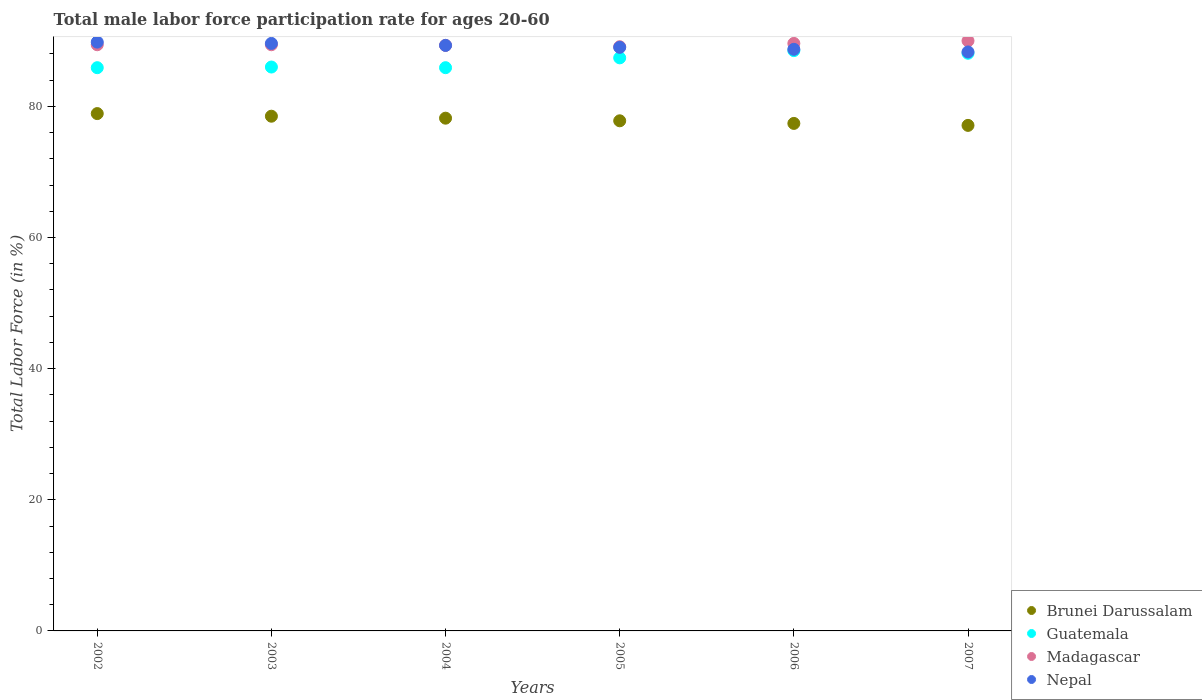How many different coloured dotlines are there?
Your response must be concise. 4. Is the number of dotlines equal to the number of legend labels?
Make the answer very short. Yes. What is the male labor force participation rate in Madagascar in 2004?
Offer a terse response. 89.3. Across all years, what is the minimum male labor force participation rate in Brunei Darussalam?
Your answer should be very brief. 77.1. In which year was the male labor force participation rate in Madagascar maximum?
Your answer should be very brief. 2007. In which year was the male labor force participation rate in Madagascar minimum?
Offer a terse response. 2005. What is the total male labor force participation rate in Madagascar in the graph?
Keep it short and to the point. 536.8. What is the difference between the male labor force participation rate in Nepal in 2003 and that in 2005?
Keep it short and to the point. 0.6. What is the difference between the male labor force participation rate in Nepal in 2003 and the male labor force participation rate in Guatemala in 2007?
Provide a succinct answer. 1.5. What is the average male labor force participation rate in Brunei Darussalam per year?
Give a very brief answer. 77.98. In the year 2005, what is the difference between the male labor force participation rate in Nepal and male labor force participation rate in Guatemala?
Provide a succinct answer. 1.6. In how many years, is the male labor force participation rate in Nepal greater than 52 %?
Offer a terse response. 6. What is the ratio of the male labor force participation rate in Nepal in 2002 to that in 2005?
Your response must be concise. 1.01. Is the male labor force participation rate in Guatemala in 2004 less than that in 2005?
Offer a very short reply. Yes. What is the difference between the highest and the second highest male labor force participation rate in Madagascar?
Provide a short and direct response. 0.4. What is the difference between the highest and the lowest male labor force participation rate in Guatemala?
Offer a terse response. 2.6. In how many years, is the male labor force participation rate in Brunei Darussalam greater than the average male labor force participation rate in Brunei Darussalam taken over all years?
Ensure brevity in your answer.  3. Does the male labor force participation rate in Madagascar monotonically increase over the years?
Give a very brief answer. No. How many dotlines are there?
Your answer should be compact. 4. What is the difference between two consecutive major ticks on the Y-axis?
Give a very brief answer. 20. Are the values on the major ticks of Y-axis written in scientific E-notation?
Make the answer very short. No. How are the legend labels stacked?
Provide a short and direct response. Vertical. What is the title of the graph?
Your answer should be compact. Total male labor force participation rate for ages 20-60. What is the label or title of the X-axis?
Ensure brevity in your answer.  Years. What is the Total Labor Force (in %) of Brunei Darussalam in 2002?
Make the answer very short. 78.9. What is the Total Labor Force (in %) in Guatemala in 2002?
Give a very brief answer. 85.9. What is the Total Labor Force (in %) in Madagascar in 2002?
Give a very brief answer. 89.4. What is the Total Labor Force (in %) in Nepal in 2002?
Your response must be concise. 89.8. What is the Total Labor Force (in %) of Brunei Darussalam in 2003?
Your answer should be compact. 78.5. What is the Total Labor Force (in %) of Madagascar in 2003?
Give a very brief answer. 89.4. What is the Total Labor Force (in %) in Nepal in 2003?
Your response must be concise. 89.6. What is the Total Labor Force (in %) in Brunei Darussalam in 2004?
Offer a terse response. 78.2. What is the Total Labor Force (in %) in Guatemala in 2004?
Provide a succinct answer. 85.9. What is the Total Labor Force (in %) of Madagascar in 2004?
Ensure brevity in your answer.  89.3. What is the Total Labor Force (in %) of Nepal in 2004?
Offer a terse response. 89.3. What is the Total Labor Force (in %) of Brunei Darussalam in 2005?
Provide a succinct answer. 77.8. What is the Total Labor Force (in %) in Guatemala in 2005?
Provide a short and direct response. 87.4. What is the Total Labor Force (in %) of Madagascar in 2005?
Your answer should be compact. 89.1. What is the Total Labor Force (in %) of Nepal in 2005?
Make the answer very short. 89. What is the Total Labor Force (in %) in Brunei Darussalam in 2006?
Ensure brevity in your answer.  77.4. What is the Total Labor Force (in %) of Guatemala in 2006?
Offer a very short reply. 88.5. What is the Total Labor Force (in %) of Madagascar in 2006?
Provide a succinct answer. 89.6. What is the Total Labor Force (in %) of Nepal in 2006?
Your response must be concise. 88.7. What is the Total Labor Force (in %) in Brunei Darussalam in 2007?
Give a very brief answer. 77.1. What is the Total Labor Force (in %) of Guatemala in 2007?
Provide a short and direct response. 88.1. What is the Total Labor Force (in %) in Nepal in 2007?
Provide a succinct answer. 88.3. Across all years, what is the maximum Total Labor Force (in %) of Brunei Darussalam?
Offer a terse response. 78.9. Across all years, what is the maximum Total Labor Force (in %) in Guatemala?
Make the answer very short. 88.5. Across all years, what is the maximum Total Labor Force (in %) in Nepal?
Keep it short and to the point. 89.8. Across all years, what is the minimum Total Labor Force (in %) of Brunei Darussalam?
Provide a succinct answer. 77.1. Across all years, what is the minimum Total Labor Force (in %) in Guatemala?
Provide a succinct answer. 85.9. Across all years, what is the minimum Total Labor Force (in %) in Madagascar?
Your answer should be very brief. 89.1. Across all years, what is the minimum Total Labor Force (in %) in Nepal?
Your answer should be very brief. 88.3. What is the total Total Labor Force (in %) of Brunei Darussalam in the graph?
Ensure brevity in your answer.  467.9. What is the total Total Labor Force (in %) of Guatemala in the graph?
Your response must be concise. 521.8. What is the total Total Labor Force (in %) in Madagascar in the graph?
Make the answer very short. 536.8. What is the total Total Labor Force (in %) in Nepal in the graph?
Your answer should be very brief. 534.7. What is the difference between the Total Labor Force (in %) in Brunei Darussalam in 2002 and that in 2003?
Your answer should be very brief. 0.4. What is the difference between the Total Labor Force (in %) of Guatemala in 2002 and that in 2003?
Your answer should be compact. -0.1. What is the difference between the Total Labor Force (in %) in Madagascar in 2002 and that in 2003?
Keep it short and to the point. 0. What is the difference between the Total Labor Force (in %) in Nepal in 2002 and that in 2003?
Offer a very short reply. 0.2. What is the difference between the Total Labor Force (in %) of Madagascar in 2002 and that in 2004?
Keep it short and to the point. 0.1. What is the difference between the Total Labor Force (in %) of Nepal in 2002 and that in 2004?
Keep it short and to the point. 0.5. What is the difference between the Total Labor Force (in %) of Madagascar in 2002 and that in 2005?
Your answer should be very brief. 0.3. What is the difference between the Total Labor Force (in %) in Guatemala in 2002 and that in 2006?
Offer a terse response. -2.6. What is the difference between the Total Labor Force (in %) in Madagascar in 2002 and that in 2006?
Provide a short and direct response. -0.2. What is the difference between the Total Labor Force (in %) of Nepal in 2002 and that in 2006?
Make the answer very short. 1.1. What is the difference between the Total Labor Force (in %) in Brunei Darussalam in 2002 and that in 2007?
Provide a succinct answer. 1.8. What is the difference between the Total Labor Force (in %) of Guatemala in 2002 and that in 2007?
Make the answer very short. -2.2. What is the difference between the Total Labor Force (in %) in Nepal in 2002 and that in 2007?
Your answer should be very brief. 1.5. What is the difference between the Total Labor Force (in %) of Brunei Darussalam in 2003 and that in 2004?
Ensure brevity in your answer.  0.3. What is the difference between the Total Labor Force (in %) of Madagascar in 2003 and that in 2004?
Offer a very short reply. 0.1. What is the difference between the Total Labor Force (in %) in Nepal in 2003 and that in 2004?
Give a very brief answer. 0.3. What is the difference between the Total Labor Force (in %) in Guatemala in 2003 and that in 2006?
Offer a very short reply. -2.5. What is the difference between the Total Labor Force (in %) in Madagascar in 2003 and that in 2006?
Keep it short and to the point. -0.2. What is the difference between the Total Labor Force (in %) of Brunei Darussalam in 2003 and that in 2007?
Provide a succinct answer. 1.4. What is the difference between the Total Labor Force (in %) in Brunei Darussalam in 2004 and that in 2005?
Provide a succinct answer. 0.4. What is the difference between the Total Labor Force (in %) in Guatemala in 2004 and that in 2005?
Offer a very short reply. -1.5. What is the difference between the Total Labor Force (in %) of Madagascar in 2004 and that in 2005?
Make the answer very short. 0.2. What is the difference between the Total Labor Force (in %) of Nepal in 2004 and that in 2005?
Provide a succinct answer. 0.3. What is the difference between the Total Labor Force (in %) of Guatemala in 2004 and that in 2006?
Your answer should be very brief. -2.6. What is the difference between the Total Labor Force (in %) in Nepal in 2004 and that in 2006?
Offer a very short reply. 0.6. What is the difference between the Total Labor Force (in %) in Guatemala in 2005 and that in 2006?
Provide a succinct answer. -1.1. What is the difference between the Total Labor Force (in %) in Madagascar in 2005 and that in 2006?
Provide a short and direct response. -0.5. What is the difference between the Total Labor Force (in %) in Guatemala in 2005 and that in 2007?
Your response must be concise. -0.7. What is the difference between the Total Labor Force (in %) of Madagascar in 2005 and that in 2007?
Give a very brief answer. -0.9. What is the difference between the Total Labor Force (in %) in Brunei Darussalam in 2006 and that in 2007?
Offer a terse response. 0.3. What is the difference between the Total Labor Force (in %) of Guatemala in 2006 and that in 2007?
Your answer should be compact. 0.4. What is the difference between the Total Labor Force (in %) of Nepal in 2006 and that in 2007?
Your answer should be very brief. 0.4. What is the difference between the Total Labor Force (in %) in Brunei Darussalam in 2002 and the Total Labor Force (in %) in Guatemala in 2003?
Offer a terse response. -7.1. What is the difference between the Total Labor Force (in %) of Brunei Darussalam in 2002 and the Total Labor Force (in %) of Nepal in 2003?
Make the answer very short. -10.7. What is the difference between the Total Labor Force (in %) of Madagascar in 2002 and the Total Labor Force (in %) of Nepal in 2003?
Offer a very short reply. -0.2. What is the difference between the Total Labor Force (in %) in Guatemala in 2002 and the Total Labor Force (in %) in Madagascar in 2004?
Your answer should be compact. -3.4. What is the difference between the Total Labor Force (in %) in Brunei Darussalam in 2002 and the Total Labor Force (in %) in Guatemala in 2005?
Keep it short and to the point. -8.5. What is the difference between the Total Labor Force (in %) of Brunei Darussalam in 2002 and the Total Labor Force (in %) of Nepal in 2005?
Provide a short and direct response. -10.1. What is the difference between the Total Labor Force (in %) of Guatemala in 2002 and the Total Labor Force (in %) of Nepal in 2005?
Give a very brief answer. -3.1. What is the difference between the Total Labor Force (in %) of Brunei Darussalam in 2002 and the Total Labor Force (in %) of Guatemala in 2006?
Ensure brevity in your answer.  -9.6. What is the difference between the Total Labor Force (in %) of Brunei Darussalam in 2002 and the Total Labor Force (in %) of Madagascar in 2006?
Provide a short and direct response. -10.7. What is the difference between the Total Labor Force (in %) in Brunei Darussalam in 2002 and the Total Labor Force (in %) in Nepal in 2006?
Provide a succinct answer. -9.8. What is the difference between the Total Labor Force (in %) in Brunei Darussalam in 2002 and the Total Labor Force (in %) in Guatemala in 2007?
Your answer should be compact. -9.2. What is the difference between the Total Labor Force (in %) of Brunei Darussalam in 2002 and the Total Labor Force (in %) of Nepal in 2007?
Provide a short and direct response. -9.4. What is the difference between the Total Labor Force (in %) of Guatemala in 2002 and the Total Labor Force (in %) of Madagascar in 2007?
Your response must be concise. -4.1. What is the difference between the Total Labor Force (in %) of Guatemala in 2002 and the Total Labor Force (in %) of Nepal in 2007?
Your response must be concise. -2.4. What is the difference between the Total Labor Force (in %) of Brunei Darussalam in 2003 and the Total Labor Force (in %) of Guatemala in 2004?
Keep it short and to the point. -7.4. What is the difference between the Total Labor Force (in %) in Brunei Darussalam in 2003 and the Total Labor Force (in %) in Madagascar in 2004?
Offer a terse response. -10.8. What is the difference between the Total Labor Force (in %) of Madagascar in 2003 and the Total Labor Force (in %) of Nepal in 2004?
Your response must be concise. 0.1. What is the difference between the Total Labor Force (in %) in Brunei Darussalam in 2003 and the Total Labor Force (in %) in Nepal in 2005?
Provide a succinct answer. -10.5. What is the difference between the Total Labor Force (in %) of Guatemala in 2003 and the Total Labor Force (in %) of Nepal in 2005?
Ensure brevity in your answer.  -3. What is the difference between the Total Labor Force (in %) in Brunei Darussalam in 2003 and the Total Labor Force (in %) in Guatemala in 2006?
Keep it short and to the point. -10. What is the difference between the Total Labor Force (in %) in Brunei Darussalam in 2003 and the Total Labor Force (in %) in Madagascar in 2006?
Give a very brief answer. -11.1. What is the difference between the Total Labor Force (in %) in Guatemala in 2003 and the Total Labor Force (in %) in Madagascar in 2006?
Your response must be concise. -3.6. What is the difference between the Total Labor Force (in %) of Madagascar in 2003 and the Total Labor Force (in %) of Nepal in 2006?
Provide a short and direct response. 0.7. What is the difference between the Total Labor Force (in %) in Brunei Darussalam in 2003 and the Total Labor Force (in %) in Guatemala in 2007?
Offer a terse response. -9.6. What is the difference between the Total Labor Force (in %) of Brunei Darussalam in 2003 and the Total Labor Force (in %) of Madagascar in 2007?
Provide a short and direct response. -11.5. What is the difference between the Total Labor Force (in %) of Guatemala in 2003 and the Total Labor Force (in %) of Madagascar in 2007?
Provide a short and direct response. -4. What is the difference between the Total Labor Force (in %) in Guatemala in 2003 and the Total Labor Force (in %) in Nepal in 2007?
Your answer should be very brief. -2.3. What is the difference between the Total Labor Force (in %) of Brunei Darussalam in 2004 and the Total Labor Force (in %) of Guatemala in 2005?
Give a very brief answer. -9.2. What is the difference between the Total Labor Force (in %) in Brunei Darussalam in 2004 and the Total Labor Force (in %) in Madagascar in 2005?
Offer a terse response. -10.9. What is the difference between the Total Labor Force (in %) in Brunei Darussalam in 2004 and the Total Labor Force (in %) in Nepal in 2005?
Offer a terse response. -10.8. What is the difference between the Total Labor Force (in %) in Madagascar in 2004 and the Total Labor Force (in %) in Nepal in 2005?
Provide a short and direct response. 0.3. What is the difference between the Total Labor Force (in %) of Brunei Darussalam in 2004 and the Total Labor Force (in %) of Guatemala in 2006?
Make the answer very short. -10.3. What is the difference between the Total Labor Force (in %) in Brunei Darussalam in 2004 and the Total Labor Force (in %) in Nepal in 2006?
Give a very brief answer. -10.5. What is the difference between the Total Labor Force (in %) of Guatemala in 2004 and the Total Labor Force (in %) of Nepal in 2006?
Make the answer very short. -2.8. What is the difference between the Total Labor Force (in %) of Brunei Darussalam in 2004 and the Total Labor Force (in %) of Guatemala in 2007?
Give a very brief answer. -9.9. What is the difference between the Total Labor Force (in %) of Brunei Darussalam in 2004 and the Total Labor Force (in %) of Nepal in 2007?
Provide a succinct answer. -10.1. What is the difference between the Total Labor Force (in %) of Brunei Darussalam in 2005 and the Total Labor Force (in %) of Guatemala in 2006?
Your answer should be compact. -10.7. What is the difference between the Total Labor Force (in %) of Brunei Darussalam in 2005 and the Total Labor Force (in %) of Nepal in 2006?
Give a very brief answer. -10.9. What is the difference between the Total Labor Force (in %) of Guatemala in 2005 and the Total Labor Force (in %) of Madagascar in 2006?
Offer a terse response. -2.2. What is the difference between the Total Labor Force (in %) in Guatemala in 2005 and the Total Labor Force (in %) in Nepal in 2006?
Give a very brief answer. -1.3. What is the difference between the Total Labor Force (in %) in Madagascar in 2005 and the Total Labor Force (in %) in Nepal in 2006?
Ensure brevity in your answer.  0.4. What is the difference between the Total Labor Force (in %) of Brunei Darussalam in 2006 and the Total Labor Force (in %) of Guatemala in 2007?
Give a very brief answer. -10.7. What is the difference between the Total Labor Force (in %) of Brunei Darussalam in 2006 and the Total Labor Force (in %) of Madagascar in 2007?
Provide a succinct answer. -12.6. What is the difference between the Total Labor Force (in %) of Brunei Darussalam in 2006 and the Total Labor Force (in %) of Nepal in 2007?
Provide a succinct answer. -10.9. What is the difference between the Total Labor Force (in %) in Madagascar in 2006 and the Total Labor Force (in %) in Nepal in 2007?
Your response must be concise. 1.3. What is the average Total Labor Force (in %) of Brunei Darussalam per year?
Provide a succinct answer. 77.98. What is the average Total Labor Force (in %) of Guatemala per year?
Keep it short and to the point. 86.97. What is the average Total Labor Force (in %) in Madagascar per year?
Make the answer very short. 89.47. What is the average Total Labor Force (in %) in Nepal per year?
Your answer should be compact. 89.12. In the year 2002, what is the difference between the Total Labor Force (in %) in Brunei Darussalam and Total Labor Force (in %) in Guatemala?
Provide a short and direct response. -7. In the year 2002, what is the difference between the Total Labor Force (in %) of Brunei Darussalam and Total Labor Force (in %) of Madagascar?
Offer a terse response. -10.5. In the year 2002, what is the difference between the Total Labor Force (in %) in Brunei Darussalam and Total Labor Force (in %) in Nepal?
Your answer should be very brief. -10.9. In the year 2002, what is the difference between the Total Labor Force (in %) of Madagascar and Total Labor Force (in %) of Nepal?
Your response must be concise. -0.4. In the year 2003, what is the difference between the Total Labor Force (in %) of Brunei Darussalam and Total Labor Force (in %) of Nepal?
Your answer should be very brief. -11.1. In the year 2003, what is the difference between the Total Labor Force (in %) in Guatemala and Total Labor Force (in %) in Nepal?
Make the answer very short. -3.6. In the year 2004, what is the difference between the Total Labor Force (in %) of Brunei Darussalam and Total Labor Force (in %) of Guatemala?
Your response must be concise. -7.7. In the year 2004, what is the difference between the Total Labor Force (in %) of Brunei Darussalam and Total Labor Force (in %) of Madagascar?
Give a very brief answer. -11.1. In the year 2004, what is the difference between the Total Labor Force (in %) in Brunei Darussalam and Total Labor Force (in %) in Nepal?
Offer a terse response. -11.1. In the year 2004, what is the difference between the Total Labor Force (in %) in Guatemala and Total Labor Force (in %) in Nepal?
Your response must be concise. -3.4. In the year 2005, what is the difference between the Total Labor Force (in %) in Brunei Darussalam and Total Labor Force (in %) in Madagascar?
Give a very brief answer. -11.3. In the year 2005, what is the difference between the Total Labor Force (in %) of Brunei Darussalam and Total Labor Force (in %) of Nepal?
Provide a succinct answer. -11.2. In the year 2005, what is the difference between the Total Labor Force (in %) in Guatemala and Total Labor Force (in %) in Madagascar?
Provide a succinct answer. -1.7. In the year 2006, what is the difference between the Total Labor Force (in %) in Brunei Darussalam and Total Labor Force (in %) in Guatemala?
Offer a terse response. -11.1. In the year 2006, what is the difference between the Total Labor Force (in %) in Brunei Darussalam and Total Labor Force (in %) in Madagascar?
Give a very brief answer. -12.2. In the year 2006, what is the difference between the Total Labor Force (in %) of Guatemala and Total Labor Force (in %) of Nepal?
Offer a very short reply. -0.2. In the year 2007, what is the difference between the Total Labor Force (in %) in Brunei Darussalam and Total Labor Force (in %) in Guatemala?
Keep it short and to the point. -11. In the year 2007, what is the difference between the Total Labor Force (in %) of Brunei Darussalam and Total Labor Force (in %) of Madagascar?
Provide a succinct answer. -12.9. In the year 2007, what is the difference between the Total Labor Force (in %) of Guatemala and Total Labor Force (in %) of Nepal?
Your answer should be very brief. -0.2. What is the ratio of the Total Labor Force (in %) in Madagascar in 2002 to that in 2003?
Provide a short and direct response. 1. What is the ratio of the Total Labor Force (in %) of Brunei Darussalam in 2002 to that in 2004?
Provide a succinct answer. 1.01. What is the ratio of the Total Labor Force (in %) in Nepal in 2002 to that in 2004?
Your answer should be compact. 1.01. What is the ratio of the Total Labor Force (in %) in Brunei Darussalam in 2002 to that in 2005?
Offer a terse response. 1.01. What is the ratio of the Total Labor Force (in %) in Guatemala in 2002 to that in 2005?
Give a very brief answer. 0.98. What is the ratio of the Total Labor Force (in %) of Madagascar in 2002 to that in 2005?
Your answer should be compact. 1. What is the ratio of the Total Labor Force (in %) of Nepal in 2002 to that in 2005?
Provide a succinct answer. 1.01. What is the ratio of the Total Labor Force (in %) in Brunei Darussalam in 2002 to that in 2006?
Keep it short and to the point. 1.02. What is the ratio of the Total Labor Force (in %) in Guatemala in 2002 to that in 2006?
Ensure brevity in your answer.  0.97. What is the ratio of the Total Labor Force (in %) of Nepal in 2002 to that in 2006?
Your response must be concise. 1.01. What is the ratio of the Total Labor Force (in %) in Brunei Darussalam in 2002 to that in 2007?
Offer a terse response. 1.02. What is the ratio of the Total Labor Force (in %) of Guatemala in 2002 to that in 2007?
Your answer should be compact. 0.97. What is the ratio of the Total Labor Force (in %) of Brunei Darussalam in 2003 to that in 2004?
Give a very brief answer. 1. What is the ratio of the Total Labor Force (in %) in Madagascar in 2003 to that in 2004?
Your response must be concise. 1. What is the ratio of the Total Labor Force (in %) of Nepal in 2003 to that in 2004?
Provide a succinct answer. 1. What is the ratio of the Total Labor Force (in %) in Brunei Darussalam in 2003 to that in 2005?
Provide a short and direct response. 1.01. What is the ratio of the Total Labor Force (in %) in Brunei Darussalam in 2003 to that in 2006?
Make the answer very short. 1.01. What is the ratio of the Total Labor Force (in %) of Guatemala in 2003 to that in 2006?
Your response must be concise. 0.97. What is the ratio of the Total Labor Force (in %) of Nepal in 2003 to that in 2006?
Keep it short and to the point. 1.01. What is the ratio of the Total Labor Force (in %) of Brunei Darussalam in 2003 to that in 2007?
Your answer should be compact. 1.02. What is the ratio of the Total Labor Force (in %) in Guatemala in 2003 to that in 2007?
Keep it short and to the point. 0.98. What is the ratio of the Total Labor Force (in %) in Madagascar in 2003 to that in 2007?
Make the answer very short. 0.99. What is the ratio of the Total Labor Force (in %) of Nepal in 2003 to that in 2007?
Provide a succinct answer. 1.01. What is the ratio of the Total Labor Force (in %) of Guatemala in 2004 to that in 2005?
Make the answer very short. 0.98. What is the ratio of the Total Labor Force (in %) of Brunei Darussalam in 2004 to that in 2006?
Offer a very short reply. 1.01. What is the ratio of the Total Labor Force (in %) of Guatemala in 2004 to that in 2006?
Your answer should be compact. 0.97. What is the ratio of the Total Labor Force (in %) in Nepal in 2004 to that in 2006?
Offer a very short reply. 1.01. What is the ratio of the Total Labor Force (in %) of Brunei Darussalam in 2004 to that in 2007?
Offer a very short reply. 1.01. What is the ratio of the Total Labor Force (in %) of Guatemala in 2004 to that in 2007?
Your response must be concise. 0.97. What is the ratio of the Total Labor Force (in %) in Nepal in 2004 to that in 2007?
Ensure brevity in your answer.  1.01. What is the ratio of the Total Labor Force (in %) of Guatemala in 2005 to that in 2006?
Provide a short and direct response. 0.99. What is the ratio of the Total Labor Force (in %) of Nepal in 2005 to that in 2006?
Make the answer very short. 1. What is the ratio of the Total Labor Force (in %) in Brunei Darussalam in 2005 to that in 2007?
Offer a very short reply. 1.01. What is the ratio of the Total Labor Force (in %) of Nepal in 2005 to that in 2007?
Make the answer very short. 1.01. What is the ratio of the Total Labor Force (in %) in Brunei Darussalam in 2006 to that in 2007?
Provide a succinct answer. 1. What is the ratio of the Total Labor Force (in %) in Guatemala in 2006 to that in 2007?
Provide a succinct answer. 1. What is the ratio of the Total Labor Force (in %) of Madagascar in 2006 to that in 2007?
Your response must be concise. 1. What is the ratio of the Total Labor Force (in %) of Nepal in 2006 to that in 2007?
Your response must be concise. 1. What is the difference between the highest and the second highest Total Labor Force (in %) of Madagascar?
Give a very brief answer. 0.4. What is the difference between the highest and the lowest Total Labor Force (in %) in Nepal?
Your answer should be very brief. 1.5. 